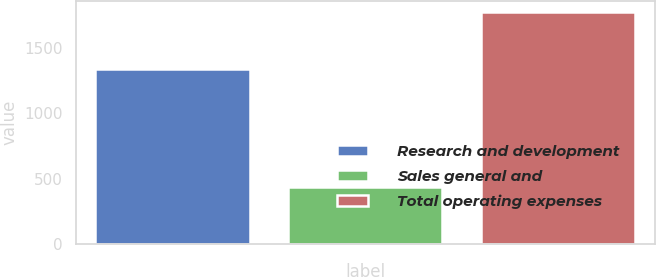<chart> <loc_0><loc_0><loc_500><loc_500><bar_chart><fcel>Research and development<fcel>Sales general and<fcel>Total operating expenses<nl><fcel>1335.8<fcel>435.7<fcel>1771.5<nl></chart> 